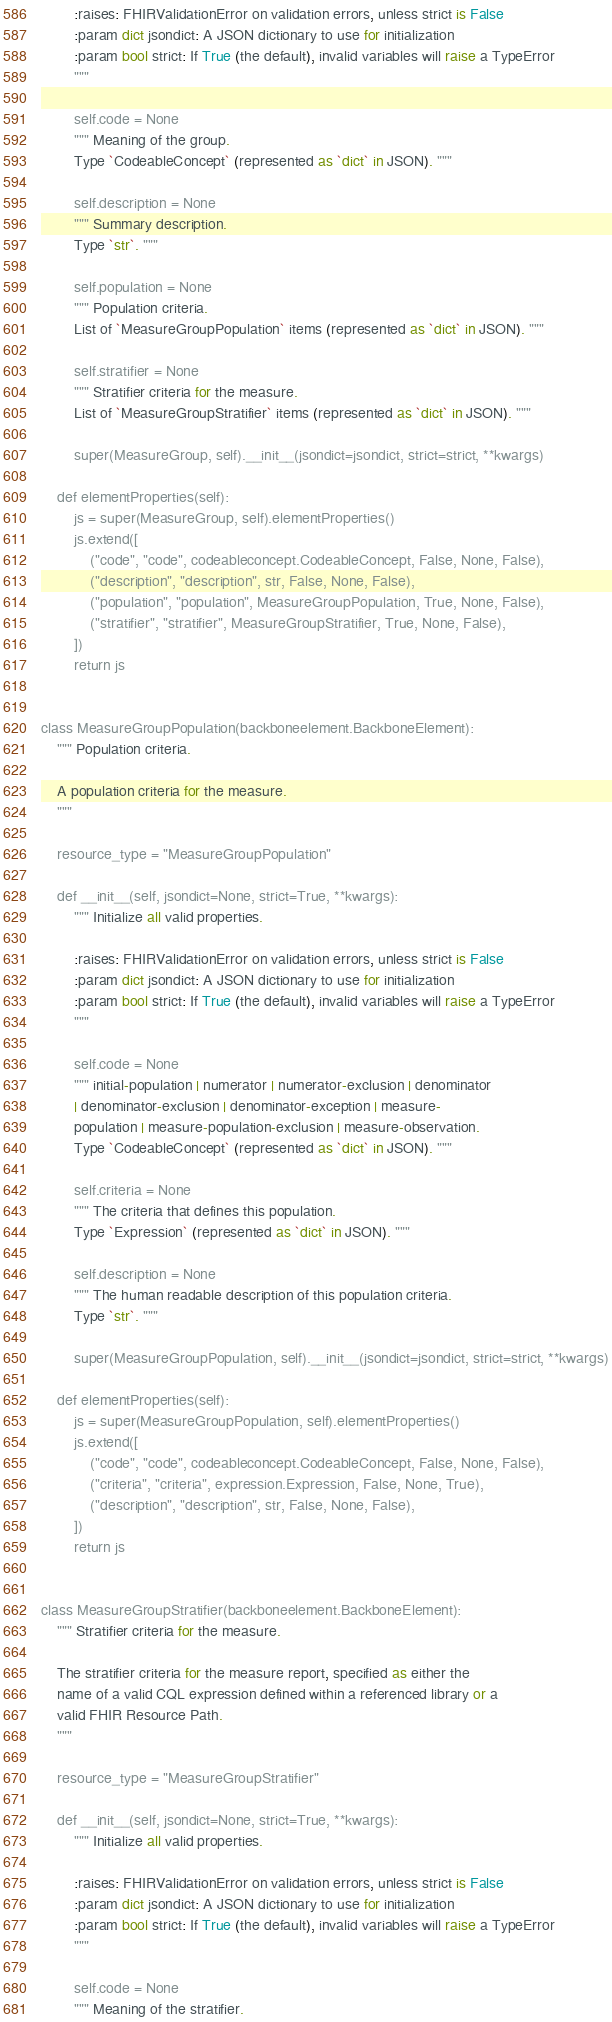Convert code to text. <code><loc_0><loc_0><loc_500><loc_500><_Python_>        :raises: FHIRValidationError on validation errors, unless strict is False
        :param dict jsondict: A JSON dictionary to use for initialization
        :param bool strict: If True (the default), invalid variables will raise a TypeError
        """

        self.code = None
        """ Meaning of the group.
        Type `CodeableConcept` (represented as `dict` in JSON). """

        self.description = None
        """ Summary description.
        Type `str`. """

        self.population = None
        """ Population criteria.
        List of `MeasureGroupPopulation` items (represented as `dict` in JSON). """

        self.stratifier = None
        """ Stratifier criteria for the measure.
        List of `MeasureGroupStratifier` items (represented as `dict` in JSON). """

        super(MeasureGroup, self).__init__(jsondict=jsondict, strict=strict, **kwargs)

    def elementProperties(self):
        js = super(MeasureGroup, self).elementProperties()
        js.extend([
            ("code", "code", codeableconcept.CodeableConcept, False, None, False),
            ("description", "description", str, False, None, False),
            ("population", "population", MeasureGroupPopulation, True, None, False),
            ("stratifier", "stratifier", MeasureGroupStratifier, True, None, False),
        ])
        return js


class MeasureGroupPopulation(backboneelement.BackboneElement):
    """ Population criteria.

    A population criteria for the measure.
    """

    resource_type = "MeasureGroupPopulation"

    def __init__(self, jsondict=None, strict=True, **kwargs):
        """ Initialize all valid properties.

        :raises: FHIRValidationError on validation errors, unless strict is False
        :param dict jsondict: A JSON dictionary to use for initialization
        :param bool strict: If True (the default), invalid variables will raise a TypeError
        """

        self.code = None
        """ initial-population | numerator | numerator-exclusion | denominator
        | denominator-exclusion | denominator-exception | measure-
        population | measure-population-exclusion | measure-observation.
        Type `CodeableConcept` (represented as `dict` in JSON). """

        self.criteria = None
        """ The criteria that defines this population.
        Type `Expression` (represented as `dict` in JSON). """

        self.description = None
        """ The human readable description of this population criteria.
        Type `str`. """

        super(MeasureGroupPopulation, self).__init__(jsondict=jsondict, strict=strict, **kwargs)

    def elementProperties(self):
        js = super(MeasureGroupPopulation, self).elementProperties()
        js.extend([
            ("code", "code", codeableconcept.CodeableConcept, False, None, False),
            ("criteria", "criteria", expression.Expression, False, None, True),
            ("description", "description", str, False, None, False),
        ])
        return js


class MeasureGroupStratifier(backboneelement.BackboneElement):
    """ Stratifier criteria for the measure.

    The stratifier criteria for the measure report, specified as either the
    name of a valid CQL expression defined within a referenced library or a
    valid FHIR Resource Path.
    """

    resource_type = "MeasureGroupStratifier"

    def __init__(self, jsondict=None, strict=True, **kwargs):
        """ Initialize all valid properties.

        :raises: FHIRValidationError on validation errors, unless strict is False
        :param dict jsondict: A JSON dictionary to use for initialization
        :param bool strict: If True (the default), invalid variables will raise a TypeError
        """

        self.code = None
        """ Meaning of the stratifier.</code> 